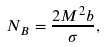<formula> <loc_0><loc_0><loc_500><loc_500>N _ { B } = \frac { 2 M ^ { 2 } b } { \sigma } ,</formula> 